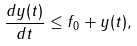<formula> <loc_0><loc_0><loc_500><loc_500>\frac { d y ( t ) } { d t } \leq f _ { 0 } + y ( t ) ,</formula> 